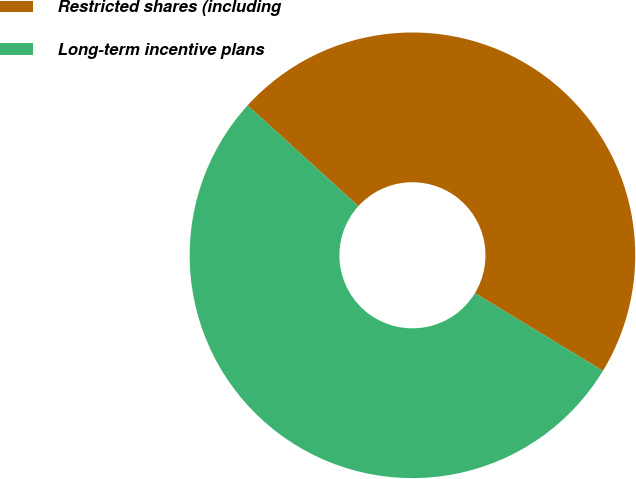<chart> <loc_0><loc_0><loc_500><loc_500><pie_chart><fcel>Restricted shares (including<fcel>Long-term incentive plans<nl><fcel>46.93%<fcel>53.07%<nl></chart> 